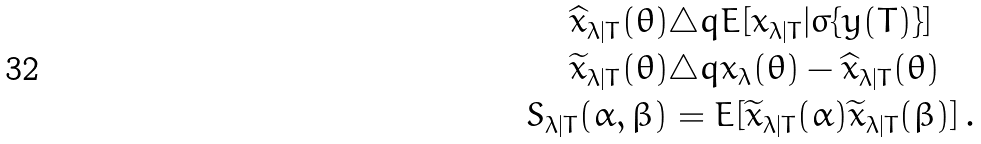<formula> <loc_0><loc_0><loc_500><loc_500>\widehat { x } _ { \lambda | T } ( \theta ) & \triangle q E [ x _ { \lambda | T } | \sigma \{ y ( T ) \} ] \\ \widetilde { x } _ { \lambda | T } ( \theta ) & \triangle q x _ { \lambda } ( \theta ) - \widehat { x } _ { \lambda | T } ( \theta ) \\ S _ { \lambda | T } ( \alpha , \beta ) & = E [ \widetilde { x } _ { \lambda | T } ( \alpha ) \widetilde { x } _ { \lambda | T } ( \beta ) ] \, .</formula> 